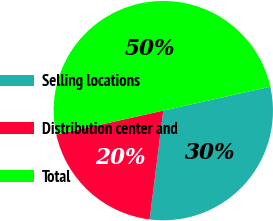<chart> <loc_0><loc_0><loc_500><loc_500><pie_chart><fcel>Selling locations<fcel>Distribution center and<fcel>Total<nl><fcel>30.5%<fcel>19.5%<fcel>50.0%<nl></chart> 